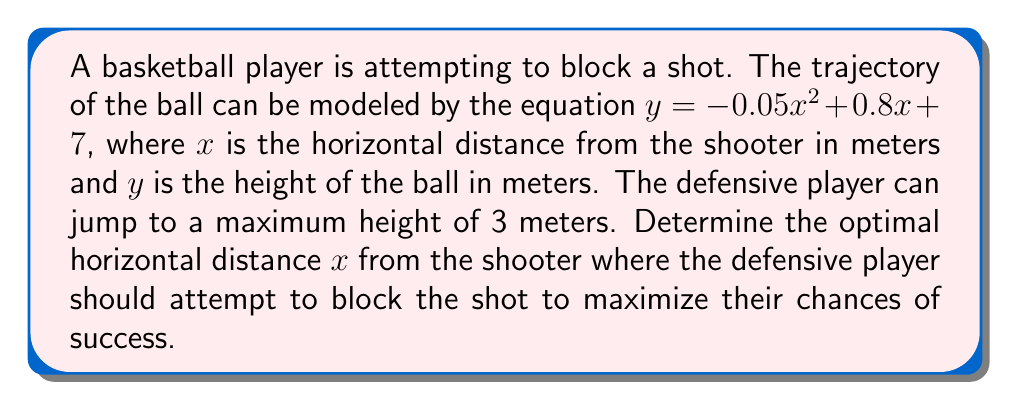Teach me how to tackle this problem. To solve this problem, we need to find the point where the difference between the ball's height and the player's maximum reach is minimized. This will give us the optimal position for the defensive player to attempt a block.

1) First, let's define a function that represents the difference between the ball's height and the player's reach:

   $f(x) = y - 3 = (-0.05x^2 + 0.8x + 7) - 3 = -0.05x^2 + 0.8x + 4$

2) To find the minimum of this function, we need to find where its derivative equals zero:

   $f'(x) = -0.1x + 0.8$

3) Set $f'(x) = 0$ and solve for $x$:

   $-0.1x + 0.8 = 0$
   $-0.1x = -0.8$
   $x = 8$

4) To confirm this is a minimum (not a maximum), we can check the second derivative:

   $f''(x) = -0.1$

   Since $f''(x)$ is negative, we confirm that $x = 8$ gives us a minimum.

5) Calculate the height of the ball at this point:

   $y = -0.05(8)^2 + 0.8(8) + 7 = -3.2 + 6.4 + 7 = 10.2$ meters

This means that at 8 meters from the shooter, the ball will be at its lowest point relative to the defender's maximum reach, giving the best chance for a successful block.
Answer: The optimal horizontal distance for the defensive player to attempt to block the shot is 8 meters from the shooter. 